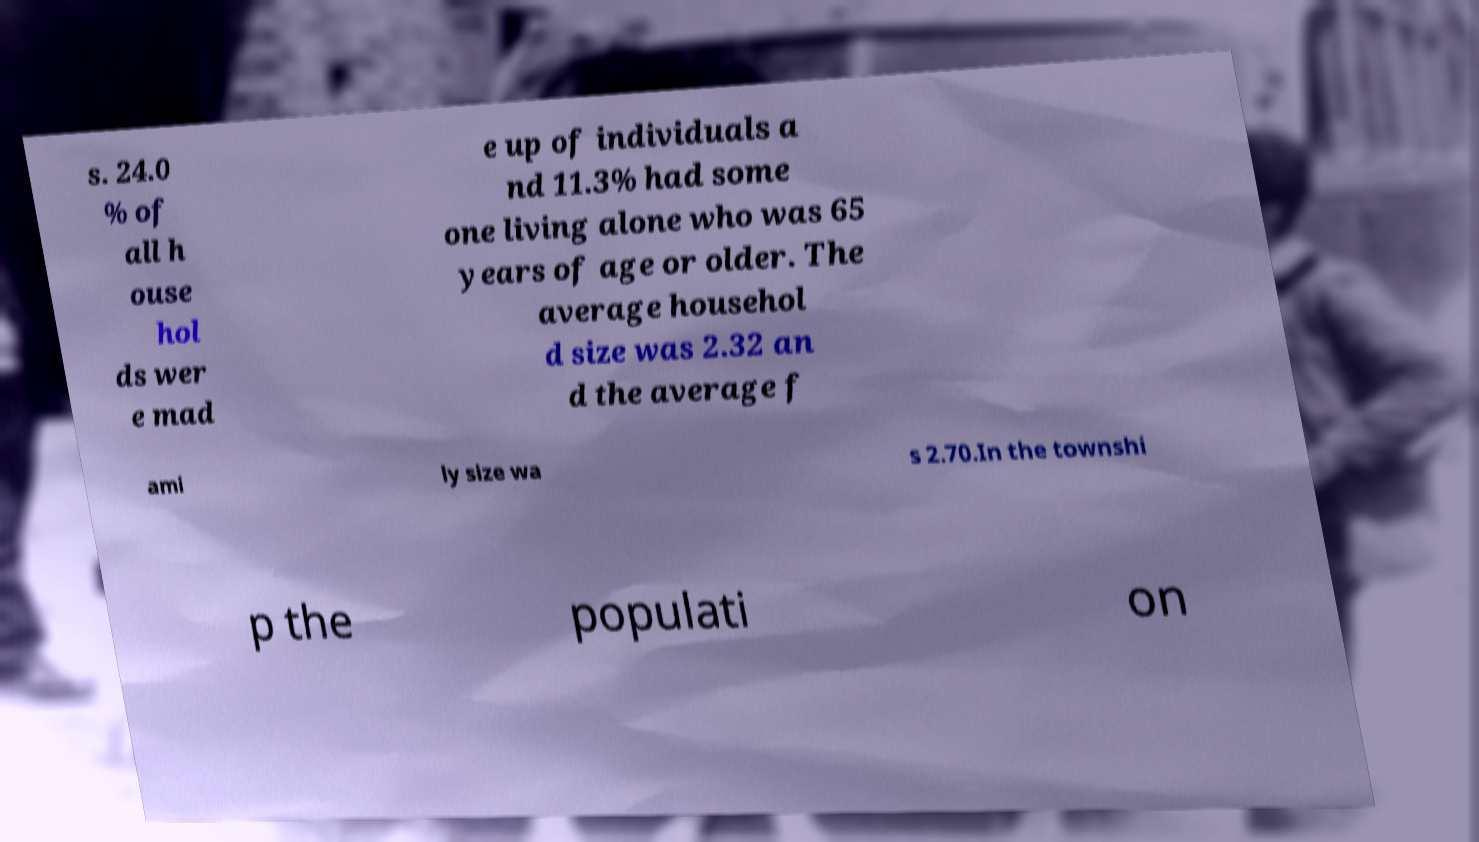Could you extract and type out the text from this image? s. 24.0 % of all h ouse hol ds wer e mad e up of individuals a nd 11.3% had some one living alone who was 65 years of age or older. The average househol d size was 2.32 an d the average f ami ly size wa s 2.70.In the townshi p the populati on 